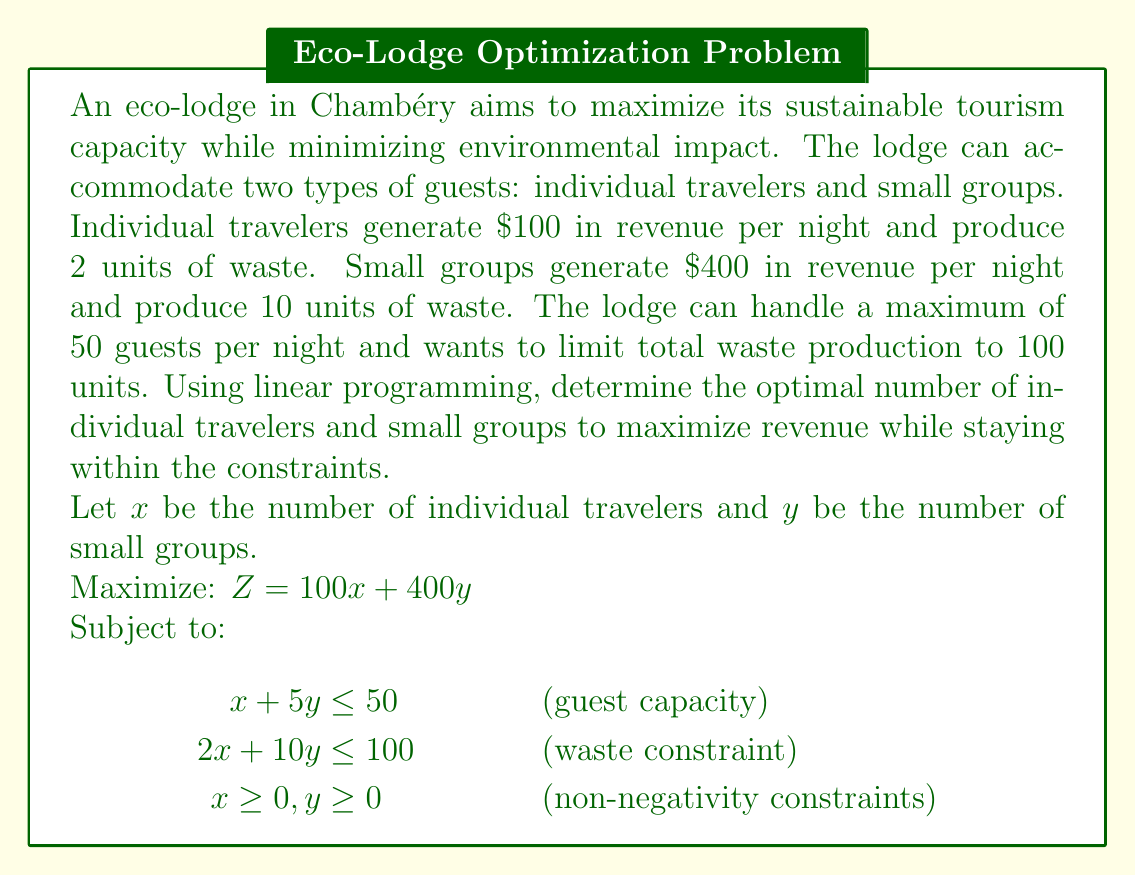Help me with this question. To solve this linear programming problem, we'll use the graphical method:

1. Plot the constraints:
   - Guest capacity: $x + 5y = 50$
   - Waste constraint: $2x + 10y = 100$, which simplifies to $x + 5y = 50$
   - Non-negativity constraints: $x \geq 0, y \geq 0$

2. Identify the feasible region:
   The feasible region is bounded by the two constraint lines and the positive x and y axes.

3. Find the corner points of the feasible region:
   - (0, 0)
   - (50, 0)
   - (0, 10)
   - (25, 5) (intersection of the two constraint lines)

4. Evaluate the objective function at each corner point:
   - $Z(0, 0) = 0$
   - $Z(50, 0) = 5000$
   - $Z(0, 10) = 4000$
   - $Z(25, 5) = 4500$

5. The maximum value of Z occurs at the point (50, 0), which represents 50 individual travelers and 0 small groups.

To verify this solution:
- Guest capacity: $50 + 5(0) = 50 \leq 50$
- Waste constraint: $2(50) + 10(0) = 100 \leq 100$

This solution satisfies all constraints and maximizes revenue.
Answer: The optimal capacity for sustainable tourism is 50 individual travelers and 0 small groups, generating a maximum revenue of $5000 per night while staying within the guest capacity and waste production constraints. 